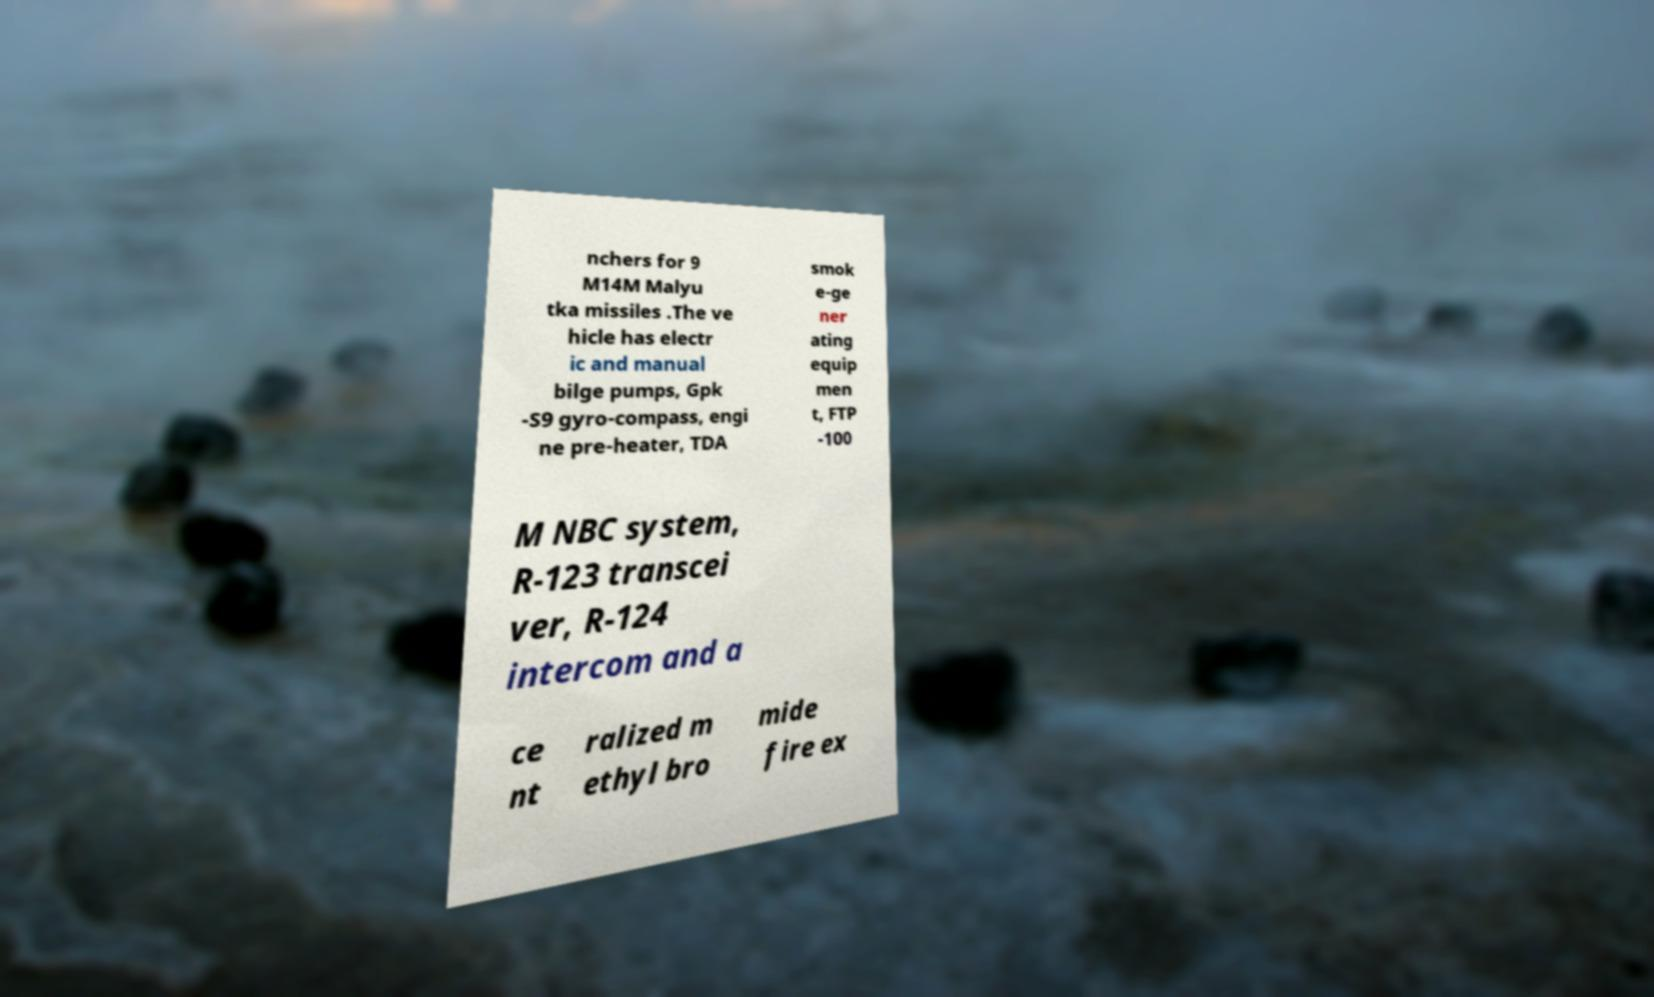There's text embedded in this image that I need extracted. Can you transcribe it verbatim? nchers for 9 M14M Malyu tka missiles .The ve hicle has electr ic and manual bilge pumps, Gpk -S9 gyro-compass, engi ne pre-heater, TDA smok e-ge ner ating equip men t, FTP -100 M NBC system, R-123 transcei ver, R-124 intercom and a ce nt ralized m ethyl bro mide fire ex 